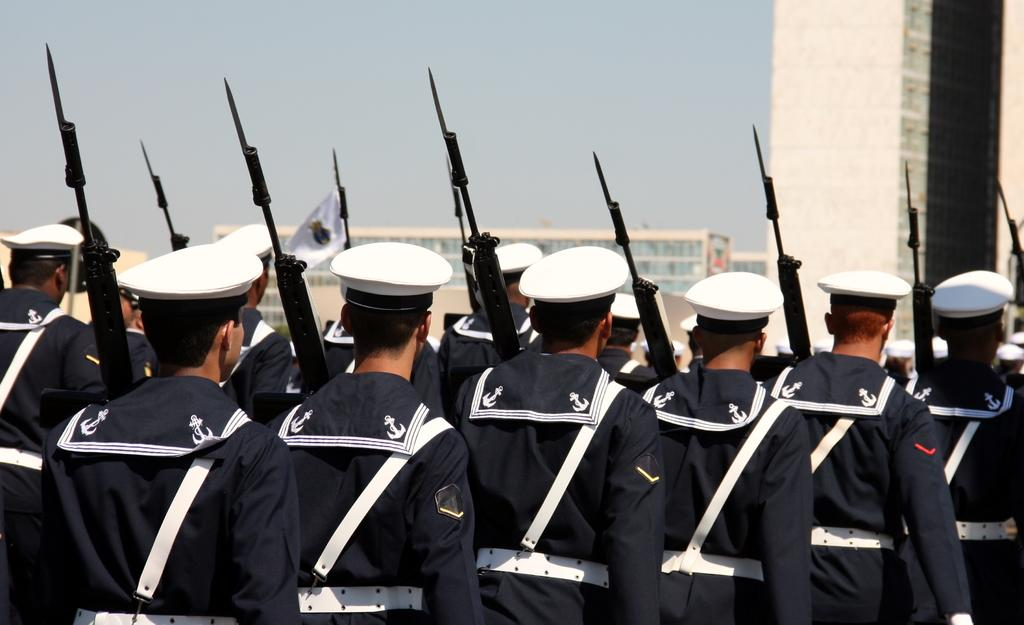Who is present in the image? There are people in the image. What are the people wearing? The people are wearing uniforms. What are the people holding in the image? The people are holding rifles. What can be seen in the background of the image? There are buildings and the sky visible in the background of the image. What type of earth can be seen in the image? There is no earth visible in the image; it is a picture of people wearing uniforms and holding rifles, with buildings and the sky in the background. 